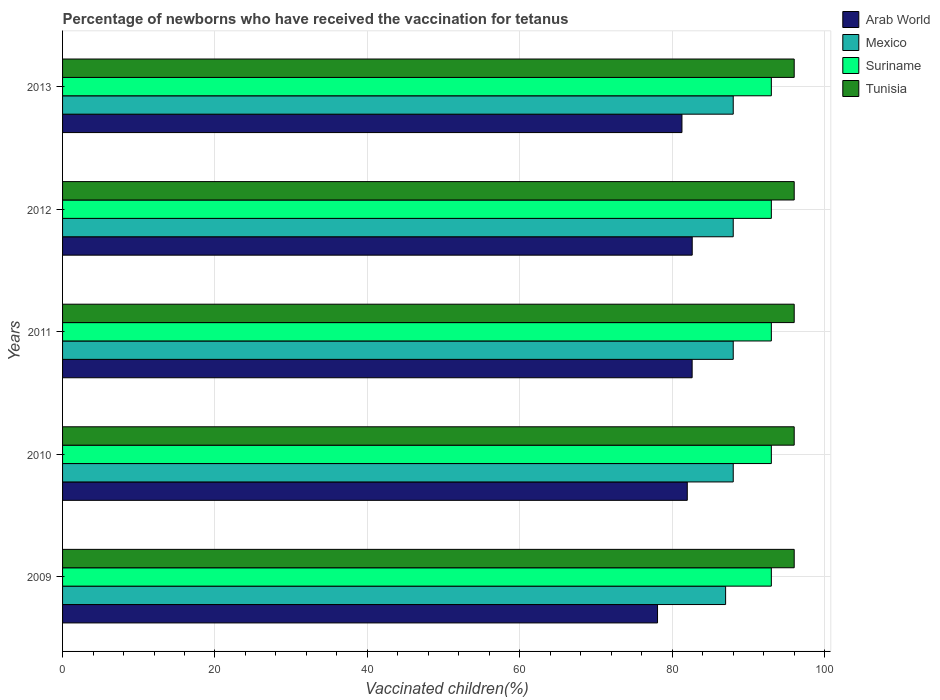How many different coloured bars are there?
Give a very brief answer. 4. How many groups of bars are there?
Offer a very short reply. 5. Are the number of bars on each tick of the Y-axis equal?
Your answer should be compact. Yes. How many bars are there on the 2nd tick from the top?
Provide a short and direct response. 4. What is the label of the 4th group of bars from the top?
Give a very brief answer. 2010. In how many cases, is the number of bars for a given year not equal to the number of legend labels?
Make the answer very short. 0. What is the percentage of vaccinated children in Tunisia in 2013?
Offer a terse response. 96. Across all years, what is the maximum percentage of vaccinated children in Tunisia?
Ensure brevity in your answer.  96. Across all years, what is the minimum percentage of vaccinated children in Tunisia?
Provide a short and direct response. 96. In which year was the percentage of vaccinated children in Mexico maximum?
Ensure brevity in your answer.  2010. What is the total percentage of vaccinated children in Mexico in the graph?
Your answer should be very brief. 439. What is the average percentage of vaccinated children in Tunisia per year?
Your response must be concise. 96. In the year 2013, what is the difference between the percentage of vaccinated children in Arab World and percentage of vaccinated children in Suriname?
Offer a very short reply. -11.73. What is the ratio of the percentage of vaccinated children in Tunisia in 2009 to that in 2012?
Give a very brief answer. 1. Is the percentage of vaccinated children in Mexico in 2010 less than that in 2011?
Your answer should be compact. No. Is the difference between the percentage of vaccinated children in Arab World in 2009 and 2010 greater than the difference between the percentage of vaccinated children in Suriname in 2009 and 2010?
Your response must be concise. No. What is the difference between the highest and the second highest percentage of vaccinated children in Arab World?
Keep it short and to the point. 0.01. What is the difference between the highest and the lowest percentage of vaccinated children in Arab World?
Provide a short and direct response. 4.55. In how many years, is the percentage of vaccinated children in Tunisia greater than the average percentage of vaccinated children in Tunisia taken over all years?
Your answer should be very brief. 0. Is it the case that in every year, the sum of the percentage of vaccinated children in Tunisia and percentage of vaccinated children in Suriname is greater than the sum of percentage of vaccinated children in Mexico and percentage of vaccinated children in Arab World?
Offer a very short reply. Yes. What does the 1st bar from the top in 2013 represents?
Your answer should be very brief. Tunisia. What does the 3rd bar from the bottom in 2009 represents?
Keep it short and to the point. Suriname. Is it the case that in every year, the sum of the percentage of vaccinated children in Mexico and percentage of vaccinated children in Suriname is greater than the percentage of vaccinated children in Tunisia?
Ensure brevity in your answer.  Yes. How many bars are there?
Provide a short and direct response. 20. Are all the bars in the graph horizontal?
Your answer should be compact. Yes. Are the values on the major ticks of X-axis written in scientific E-notation?
Provide a short and direct response. No. Does the graph contain any zero values?
Provide a short and direct response. No. Does the graph contain grids?
Ensure brevity in your answer.  Yes. Where does the legend appear in the graph?
Offer a very short reply. Top right. How are the legend labels stacked?
Keep it short and to the point. Vertical. What is the title of the graph?
Your answer should be compact. Percentage of newborns who have received the vaccination for tetanus. What is the label or title of the X-axis?
Ensure brevity in your answer.  Vaccinated children(%). What is the label or title of the Y-axis?
Keep it short and to the point. Years. What is the Vaccinated children(%) in Arab World in 2009?
Offer a very short reply. 78.07. What is the Vaccinated children(%) of Suriname in 2009?
Offer a very short reply. 93. What is the Vaccinated children(%) of Tunisia in 2009?
Your response must be concise. 96. What is the Vaccinated children(%) of Arab World in 2010?
Offer a very short reply. 81.97. What is the Vaccinated children(%) of Suriname in 2010?
Make the answer very short. 93. What is the Vaccinated children(%) in Tunisia in 2010?
Ensure brevity in your answer.  96. What is the Vaccinated children(%) of Arab World in 2011?
Your answer should be compact. 82.61. What is the Vaccinated children(%) of Mexico in 2011?
Your response must be concise. 88. What is the Vaccinated children(%) of Suriname in 2011?
Ensure brevity in your answer.  93. What is the Vaccinated children(%) of Tunisia in 2011?
Provide a succinct answer. 96. What is the Vaccinated children(%) of Arab World in 2012?
Give a very brief answer. 82.62. What is the Vaccinated children(%) of Mexico in 2012?
Ensure brevity in your answer.  88. What is the Vaccinated children(%) of Suriname in 2012?
Make the answer very short. 93. What is the Vaccinated children(%) of Tunisia in 2012?
Your answer should be compact. 96. What is the Vaccinated children(%) in Arab World in 2013?
Your answer should be compact. 81.27. What is the Vaccinated children(%) in Mexico in 2013?
Your answer should be compact. 88. What is the Vaccinated children(%) of Suriname in 2013?
Your response must be concise. 93. What is the Vaccinated children(%) of Tunisia in 2013?
Provide a succinct answer. 96. Across all years, what is the maximum Vaccinated children(%) in Arab World?
Your answer should be compact. 82.62. Across all years, what is the maximum Vaccinated children(%) of Mexico?
Provide a short and direct response. 88. Across all years, what is the maximum Vaccinated children(%) in Suriname?
Provide a succinct answer. 93. Across all years, what is the maximum Vaccinated children(%) of Tunisia?
Make the answer very short. 96. Across all years, what is the minimum Vaccinated children(%) in Arab World?
Your answer should be very brief. 78.07. Across all years, what is the minimum Vaccinated children(%) of Suriname?
Ensure brevity in your answer.  93. Across all years, what is the minimum Vaccinated children(%) of Tunisia?
Keep it short and to the point. 96. What is the total Vaccinated children(%) of Arab World in the graph?
Provide a succinct answer. 406.53. What is the total Vaccinated children(%) of Mexico in the graph?
Ensure brevity in your answer.  439. What is the total Vaccinated children(%) in Suriname in the graph?
Give a very brief answer. 465. What is the total Vaccinated children(%) of Tunisia in the graph?
Your answer should be compact. 480. What is the difference between the Vaccinated children(%) in Arab World in 2009 and that in 2010?
Your answer should be very brief. -3.9. What is the difference between the Vaccinated children(%) of Mexico in 2009 and that in 2010?
Your answer should be compact. -1. What is the difference between the Vaccinated children(%) of Arab World in 2009 and that in 2011?
Give a very brief answer. -4.54. What is the difference between the Vaccinated children(%) of Tunisia in 2009 and that in 2011?
Your response must be concise. 0. What is the difference between the Vaccinated children(%) of Arab World in 2009 and that in 2012?
Offer a very short reply. -4.55. What is the difference between the Vaccinated children(%) of Tunisia in 2009 and that in 2012?
Offer a very short reply. 0. What is the difference between the Vaccinated children(%) in Arab World in 2009 and that in 2013?
Your answer should be compact. -3.2. What is the difference between the Vaccinated children(%) of Mexico in 2009 and that in 2013?
Your answer should be compact. -1. What is the difference between the Vaccinated children(%) of Suriname in 2009 and that in 2013?
Your answer should be very brief. 0. What is the difference between the Vaccinated children(%) of Tunisia in 2009 and that in 2013?
Give a very brief answer. 0. What is the difference between the Vaccinated children(%) of Arab World in 2010 and that in 2011?
Your answer should be very brief. -0.64. What is the difference between the Vaccinated children(%) of Arab World in 2010 and that in 2012?
Offer a very short reply. -0.65. What is the difference between the Vaccinated children(%) in Mexico in 2010 and that in 2012?
Offer a very short reply. 0. What is the difference between the Vaccinated children(%) in Suriname in 2010 and that in 2012?
Your answer should be very brief. 0. What is the difference between the Vaccinated children(%) in Arab World in 2011 and that in 2012?
Give a very brief answer. -0.01. What is the difference between the Vaccinated children(%) in Suriname in 2011 and that in 2012?
Provide a short and direct response. 0. What is the difference between the Vaccinated children(%) in Tunisia in 2011 and that in 2012?
Offer a terse response. 0. What is the difference between the Vaccinated children(%) of Arab World in 2011 and that in 2013?
Provide a succinct answer. 1.34. What is the difference between the Vaccinated children(%) of Suriname in 2011 and that in 2013?
Ensure brevity in your answer.  0. What is the difference between the Vaccinated children(%) in Tunisia in 2011 and that in 2013?
Give a very brief answer. 0. What is the difference between the Vaccinated children(%) of Arab World in 2012 and that in 2013?
Provide a short and direct response. 1.35. What is the difference between the Vaccinated children(%) of Mexico in 2012 and that in 2013?
Provide a succinct answer. 0. What is the difference between the Vaccinated children(%) of Tunisia in 2012 and that in 2013?
Ensure brevity in your answer.  0. What is the difference between the Vaccinated children(%) in Arab World in 2009 and the Vaccinated children(%) in Mexico in 2010?
Your answer should be very brief. -9.93. What is the difference between the Vaccinated children(%) of Arab World in 2009 and the Vaccinated children(%) of Suriname in 2010?
Ensure brevity in your answer.  -14.93. What is the difference between the Vaccinated children(%) of Arab World in 2009 and the Vaccinated children(%) of Tunisia in 2010?
Ensure brevity in your answer.  -17.93. What is the difference between the Vaccinated children(%) in Mexico in 2009 and the Vaccinated children(%) in Suriname in 2010?
Provide a succinct answer. -6. What is the difference between the Vaccinated children(%) in Mexico in 2009 and the Vaccinated children(%) in Tunisia in 2010?
Offer a terse response. -9. What is the difference between the Vaccinated children(%) of Arab World in 2009 and the Vaccinated children(%) of Mexico in 2011?
Provide a short and direct response. -9.93. What is the difference between the Vaccinated children(%) in Arab World in 2009 and the Vaccinated children(%) in Suriname in 2011?
Provide a short and direct response. -14.93. What is the difference between the Vaccinated children(%) of Arab World in 2009 and the Vaccinated children(%) of Tunisia in 2011?
Ensure brevity in your answer.  -17.93. What is the difference between the Vaccinated children(%) of Mexico in 2009 and the Vaccinated children(%) of Suriname in 2011?
Offer a terse response. -6. What is the difference between the Vaccinated children(%) in Arab World in 2009 and the Vaccinated children(%) in Mexico in 2012?
Make the answer very short. -9.93. What is the difference between the Vaccinated children(%) in Arab World in 2009 and the Vaccinated children(%) in Suriname in 2012?
Keep it short and to the point. -14.93. What is the difference between the Vaccinated children(%) in Arab World in 2009 and the Vaccinated children(%) in Tunisia in 2012?
Provide a short and direct response. -17.93. What is the difference between the Vaccinated children(%) in Mexico in 2009 and the Vaccinated children(%) in Suriname in 2012?
Provide a short and direct response. -6. What is the difference between the Vaccinated children(%) of Mexico in 2009 and the Vaccinated children(%) of Tunisia in 2012?
Keep it short and to the point. -9. What is the difference between the Vaccinated children(%) in Suriname in 2009 and the Vaccinated children(%) in Tunisia in 2012?
Offer a very short reply. -3. What is the difference between the Vaccinated children(%) of Arab World in 2009 and the Vaccinated children(%) of Mexico in 2013?
Make the answer very short. -9.93. What is the difference between the Vaccinated children(%) of Arab World in 2009 and the Vaccinated children(%) of Suriname in 2013?
Provide a short and direct response. -14.93. What is the difference between the Vaccinated children(%) in Arab World in 2009 and the Vaccinated children(%) in Tunisia in 2013?
Your answer should be very brief. -17.93. What is the difference between the Vaccinated children(%) of Mexico in 2009 and the Vaccinated children(%) of Suriname in 2013?
Provide a succinct answer. -6. What is the difference between the Vaccinated children(%) in Arab World in 2010 and the Vaccinated children(%) in Mexico in 2011?
Provide a short and direct response. -6.03. What is the difference between the Vaccinated children(%) in Arab World in 2010 and the Vaccinated children(%) in Suriname in 2011?
Offer a very short reply. -11.03. What is the difference between the Vaccinated children(%) of Arab World in 2010 and the Vaccinated children(%) of Tunisia in 2011?
Your answer should be compact. -14.03. What is the difference between the Vaccinated children(%) of Mexico in 2010 and the Vaccinated children(%) of Tunisia in 2011?
Make the answer very short. -8. What is the difference between the Vaccinated children(%) in Suriname in 2010 and the Vaccinated children(%) in Tunisia in 2011?
Offer a very short reply. -3. What is the difference between the Vaccinated children(%) in Arab World in 2010 and the Vaccinated children(%) in Mexico in 2012?
Offer a terse response. -6.03. What is the difference between the Vaccinated children(%) of Arab World in 2010 and the Vaccinated children(%) of Suriname in 2012?
Make the answer very short. -11.03. What is the difference between the Vaccinated children(%) in Arab World in 2010 and the Vaccinated children(%) in Tunisia in 2012?
Give a very brief answer. -14.03. What is the difference between the Vaccinated children(%) of Mexico in 2010 and the Vaccinated children(%) of Suriname in 2012?
Ensure brevity in your answer.  -5. What is the difference between the Vaccinated children(%) of Mexico in 2010 and the Vaccinated children(%) of Tunisia in 2012?
Keep it short and to the point. -8. What is the difference between the Vaccinated children(%) in Arab World in 2010 and the Vaccinated children(%) in Mexico in 2013?
Your response must be concise. -6.03. What is the difference between the Vaccinated children(%) in Arab World in 2010 and the Vaccinated children(%) in Suriname in 2013?
Your answer should be compact. -11.03. What is the difference between the Vaccinated children(%) of Arab World in 2010 and the Vaccinated children(%) of Tunisia in 2013?
Ensure brevity in your answer.  -14.03. What is the difference between the Vaccinated children(%) of Mexico in 2010 and the Vaccinated children(%) of Tunisia in 2013?
Your answer should be very brief. -8. What is the difference between the Vaccinated children(%) of Suriname in 2010 and the Vaccinated children(%) of Tunisia in 2013?
Keep it short and to the point. -3. What is the difference between the Vaccinated children(%) in Arab World in 2011 and the Vaccinated children(%) in Mexico in 2012?
Offer a very short reply. -5.39. What is the difference between the Vaccinated children(%) of Arab World in 2011 and the Vaccinated children(%) of Suriname in 2012?
Provide a short and direct response. -10.39. What is the difference between the Vaccinated children(%) in Arab World in 2011 and the Vaccinated children(%) in Tunisia in 2012?
Keep it short and to the point. -13.39. What is the difference between the Vaccinated children(%) in Mexico in 2011 and the Vaccinated children(%) in Suriname in 2012?
Make the answer very short. -5. What is the difference between the Vaccinated children(%) of Mexico in 2011 and the Vaccinated children(%) of Tunisia in 2012?
Your response must be concise. -8. What is the difference between the Vaccinated children(%) of Suriname in 2011 and the Vaccinated children(%) of Tunisia in 2012?
Provide a short and direct response. -3. What is the difference between the Vaccinated children(%) in Arab World in 2011 and the Vaccinated children(%) in Mexico in 2013?
Your response must be concise. -5.39. What is the difference between the Vaccinated children(%) in Arab World in 2011 and the Vaccinated children(%) in Suriname in 2013?
Your response must be concise. -10.39. What is the difference between the Vaccinated children(%) of Arab World in 2011 and the Vaccinated children(%) of Tunisia in 2013?
Your answer should be very brief. -13.39. What is the difference between the Vaccinated children(%) in Arab World in 2012 and the Vaccinated children(%) in Mexico in 2013?
Offer a terse response. -5.38. What is the difference between the Vaccinated children(%) in Arab World in 2012 and the Vaccinated children(%) in Suriname in 2013?
Provide a short and direct response. -10.38. What is the difference between the Vaccinated children(%) of Arab World in 2012 and the Vaccinated children(%) of Tunisia in 2013?
Give a very brief answer. -13.38. What is the difference between the Vaccinated children(%) of Mexico in 2012 and the Vaccinated children(%) of Suriname in 2013?
Make the answer very short. -5. What is the difference between the Vaccinated children(%) in Mexico in 2012 and the Vaccinated children(%) in Tunisia in 2013?
Offer a terse response. -8. What is the average Vaccinated children(%) of Arab World per year?
Offer a terse response. 81.31. What is the average Vaccinated children(%) of Mexico per year?
Ensure brevity in your answer.  87.8. What is the average Vaccinated children(%) in Suriname per year?
Provide a succinct answer. 93. What is the average Vaccinated children(%) of Tunisia per year?
Give a very brief answer. 96. In the year 2009, what is the difference between the Vaccinated children(%) in Arab World and Vaccinated children(%) in Mexico?
Make the answer very short. -8.93. In the year 2009, what is the difference between the Vaccinated children(%) of Arab World and Vaccinated children(%) of Suriname?
Make the answer very short. -14.93. In the year 2009, what is the difference between the Vaccinated children(%) of Arab World and Vaccinated children(%) of Tunisia?
Offer a very short reply. -17.93. In the year 2009, what is the difference between the Vaccinated children(%) in Mexico and Vaccinated children(%) in Suriname?
Your response must be concise. -6. In the year 2009, what is the difference between the Vaccinated children(%) in Mexico and Vaccinated children(%) in Tunisia?
Offer a terse response. -9. In the year 2010, what is the difference between the Vaccinated children(%) of Arab World and Vaccinated children(%) of Mexico?
Your answer should be compact. -6.03. In the year 2010, what is the difference between the Vaccinated children(%) of Arab World and Vaccinated children(%) of Suriname?
Make the answer very short. -11.03. In the year 2010, what is the difference between the Vaccinated children(%) of Arab World and Vaccinated children(%) of Tunisia?
Your response must be concise. -14.03. In the year 2010, what is the difference between the Vaccinated children(%) in Mexico and Vaccinated children(%) in Tunisia?
Keep it short and to the point. -8. In the year 2010, what is the difference between the Vaccinated children(%) of Suriname and Vaccinated children(%) of Tunisia?
Your answer should be very brief. -3. In the year 2011, what is the difference between the Vaccinated children(%) of Arab World and Vaccinated children(%) of Mexico?
Offer a terse response. -5.39. In the year 2011, what is the difference between the Vaccinated children(%) of Arab World and Vaccinated children(%) of Suriname?
Offer a very short reply. -10.39. In the year 2011, what is the difference between the Vaccinated children(%) in Arab World and Vaccinated children(%) in Tunisia?
Provide a succinct answer. -13.39. In the year 2011, what is the difference between the Vaccinated children(%) in Mexico and Vaccinated children(%) in Suriname?
Provide a short and direct response. -5. In the year 2011, what is the difference between the Vaccinated children(%) in Mexico and Vaccinated children(%) in Tunisia?
Provide a succinct answer. -8. In the year 2011, what is the difference between the Vaccinated children(%) of Suriname and Vaccinated children(%) of Tunisia?
Your answer should be very brief. -3. In the year 2012, what is the difference between the Vaccinated children(%) in Arab World and Vaccinated children(%) in Mexico?
Provide a short and direct response. -5.38. In the year 2012, what is the difference between the Vaccinated children(%) of Arab World and Vaccinated children(%) of Suriname?
Keep it short and to the point. -10.38. In the year 2012, what is the difference between the Vaccinated children(%) in Arab World and Vaccinated children(%) in Tunisia?
Offer a very short reply. -13.38. In the year 2012, what is the difference between the Vaccinated children(%) of Mexico and Vaccinated children(%) of Tunisia?
Your answer should be compact. -8. In the year 2013, what is the difference between the Vaccinated children(%) of Arab World and Vaccinated children(%) of Mexico?
Give a very brief answer. -6.73. In the year 2013, what is the difference between the Vaccinated children(%) of Arab World and Vaccinated children(%) of Suriname?
Offer a very short reply. -11.73. In the year 2013, what is the difference between the Vaccinated children(%) in Arab World and Vaccinated children(%) in Tunisia?
Keep it short and to the point. -14.73. In the year 2013, what is the difference between the Vaccinated children(%) of Suriname and Vaccinated children(%) of Tunisia?
Provide a succinct answer. -3. What is the ratio of the Vaccinated children(%) of Arab World in 2009 to that in 2010?
Your answer should be compact. 0.95. What is the ratio of the Vaccinated children(%) in Mexico in 2009 to that in 2010?
Provide a short and direct response. 0.99. What is the ratio of the Vaccinated children(%) in Suriname in 2009 to that in 2010?
Offer a terse response. 1. What is the ratio of the Vaccinated children(%) in Tunisia in 2009 to that in 2010?
Provide a short and direct response. 1. What is the ratio of the Vaccinated children(%) in Arab World in 2009 to that in 2011?
Offer a terse response. 0.94. What is the ratio of the Vaccinated children(%) of Tunisia in 2009 to that in 2011?
Make the answer very short. 1. What is the ratio of the Vaccinated children(%) of Arab World in 2009 to that in 2012?
Provide a succinct answer. 0.94. What is the ratio of the Vaccinated children(%) of Mexico in 2009 to that in 2012?
Keep it short and to the point. 0.99. What is the ratio of the Vaccinated children(%) in Suriname in 2009 to that in 2012?
Provide a short and direct response. 1. What is the ratio of the Vaccinated children(%) in Tunisia in 2009 to that in 2012?
Offer a very short reply. 1. What is the ratio of the Vaccinated children(%) of Arab World in 2009 to that in 2013?
Your answer should be compact. 0.96. What is the ratio of the Vaccinated children(%) of Tunisia in 2009 to that in 2013?
Make the answer very short. 1. What is the ratio of the Vaccinated children(%) of Arab World in 2010 to that in 2011?
Your answer should be compact. 0.99. What is the ratio of the Vaccinated children(%) in Suriname in 2010 to that in 2012?
Keep it short and to the point. 1. What is the ratio of the Vaccinated children(%) in Arab World in 2010 to that in 2013?
Your answer should be compact. 1.01. What is the ratio of the Vaccinated children(%) in Suriname in 2010 to that in 2013?
Provide a succinct answer. 1. What is the ratio of the Vaccinated children(%) in Arab World in 2011 to that in 2012?
Make the answer very short. 1. What is the ratio of the Vaccinated children(%) of Mexico in 2011 to that in 2012?
Provide a short and direct response. 1. What is the ratio of the Vaccinated children(%) of Arab World in 2011 to that in 2013?
Your answer should be very brief. 1.02. What is the ratio of the Vaccinated children(%) in Mexico in 2011 to that in 2013?
Provide a succinct answer. 1. What is the ratio of the Vaccinated children(%) of Arab World in 2012 to that in 2013?
Offer a very short reply. 1.02. What is the ratio of the Vaccinated children(%) in Suriname in 2012 to that in 2013?
Provide a succinct answer. 1. What is the difference between the highest and the second highest Vaccinated children(%) in Arab World?
Your answer should be compact. 0.01. What is the difference between the highest and the lowest Vaccinated children(%) of Arab World?
Your answer should be very brief. 4.55. What is the difference between the highest and the lowest Vaccinated children(%) of Mexico?
Provide a short and direct response. 1. 